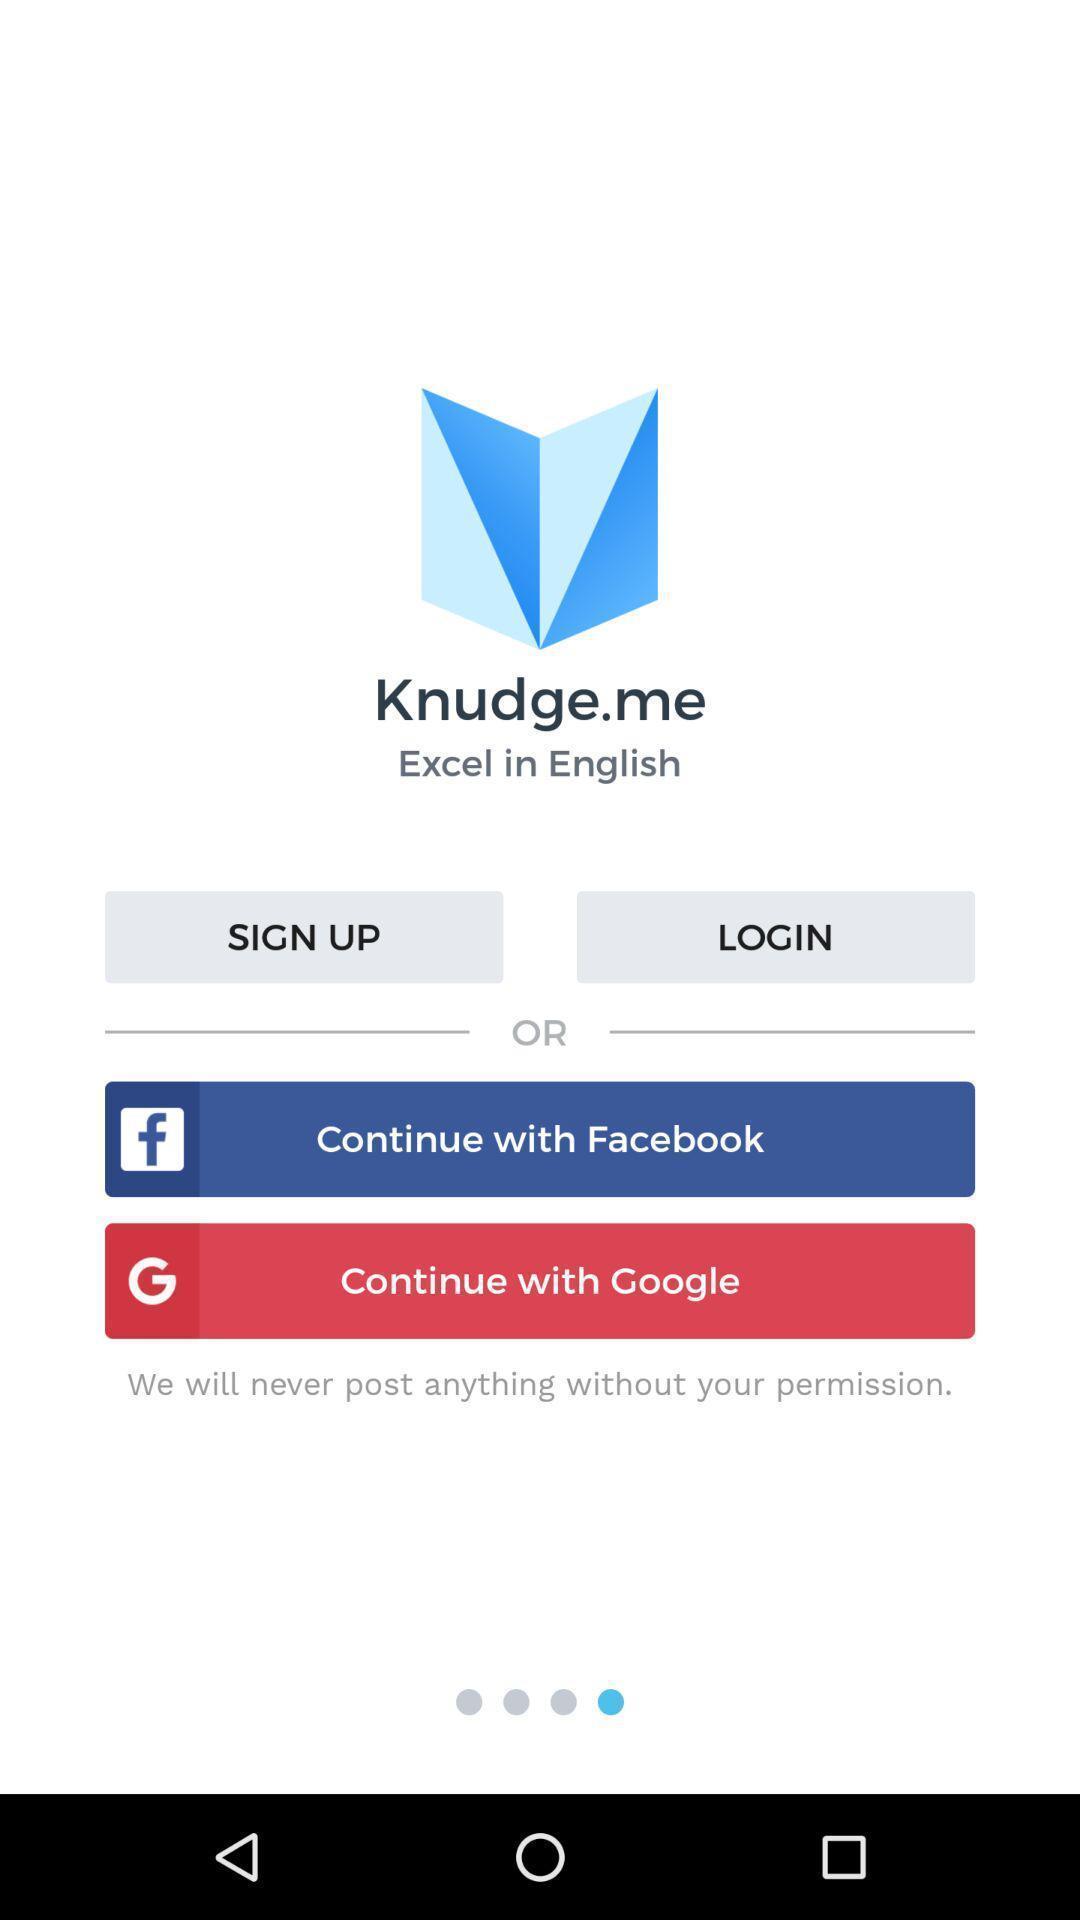Give me a narrative description of this picture. Signup page of excel in english app. 